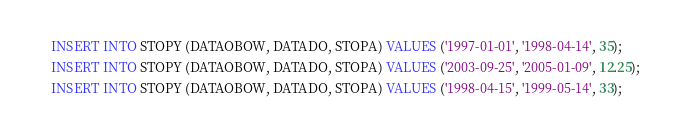<code> <loc_0><loc_0><loc_500><loc_500><_SQL_>INSERT INTO STOPY (DATAOBOW, DATADO, STOPA) VALUES ('1997-01-01', '1998-04-14', 35);
INSERT INTO STOPY (DATAOBOW, DATADO, STOPA) VALUES ('2003-09-25', '2005-01-09', 12.25);
INSERT INTO STOPY (DATAOBOW, DATADO, STOPA) VALUES ('1998-04-15', '1999-05-14', 33);</code> 